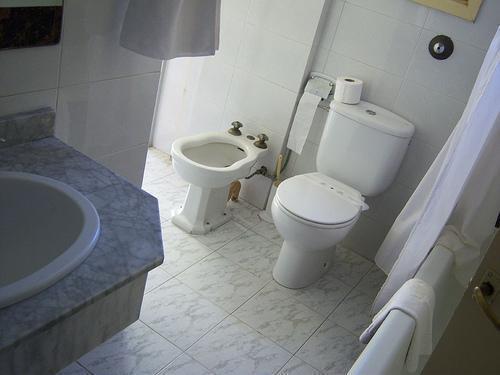Why is the toilet paper on top of the toilet?
Indicate the correct choice and explain in the format: 'Answer: answer
Rationale: rationale.'
Options: Easy access, reduce noise, safety, aesthetics. Answer: easy access.
Rationale: Since it is located behing the toilet, it is in easy reach for the person needing access to it. 